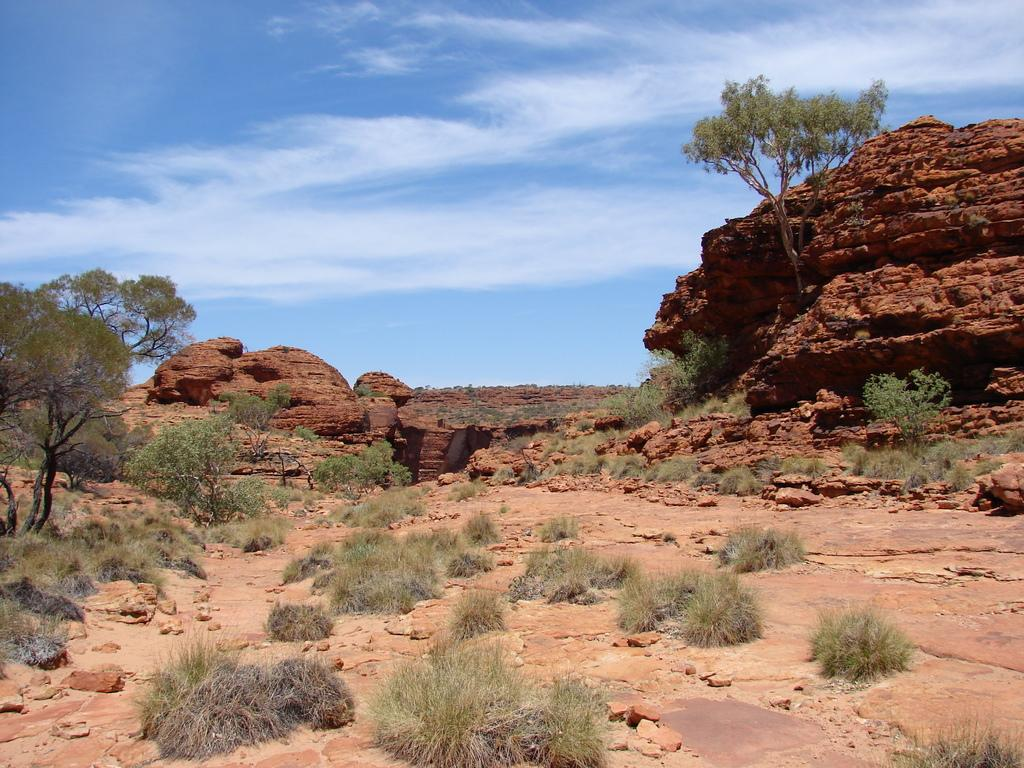What type of vegetation is present in the image? There is grass, plants, and trees in the image. What other natural elements can be seen in the image? There are rocks in the image. What is visible in the background of the image? The background of the image includes rocks. What part of the natural environment is visible at the top of the image? The sky is visible at the top of the image. How many plastic snails can be seen crawling on the rocks in the image? There are no plastic snails present in the image; it features natural elements such as grass, plants, trees, and rocks. 